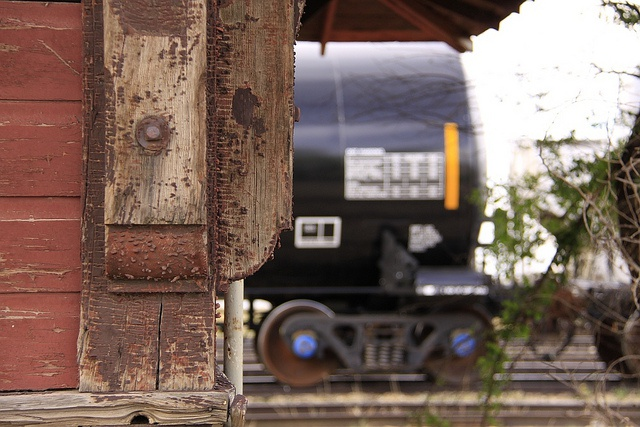Describe the objects in this image and their specific colors. I can see a train in brown, black, gray, and darkgray tones in this image. 